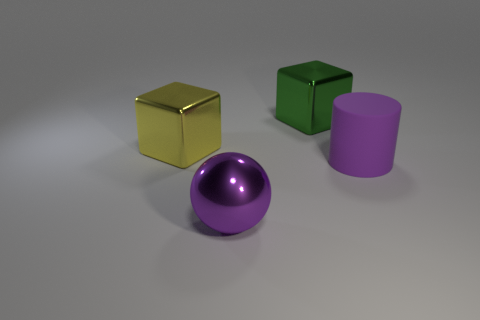Subtract 1 cylinders. How many cylinders are left? 0 Add 2 purple cylinders. How many objects exist? 6 Subtract all green balls. How many yellow cubes are left? 1 Subtract 0 brown cylinders. How many objects are left? 4 Subtract all gray cylinders. Subtract all yellow balls. How many cylinders are left? 1 Subtract all large metallic things. Subtract all large matte things. How many objects are left? 0 Add 3 large spheres. How many large spheres are left? 4 Add 4 big blocks. How many big blocks exist? 6 